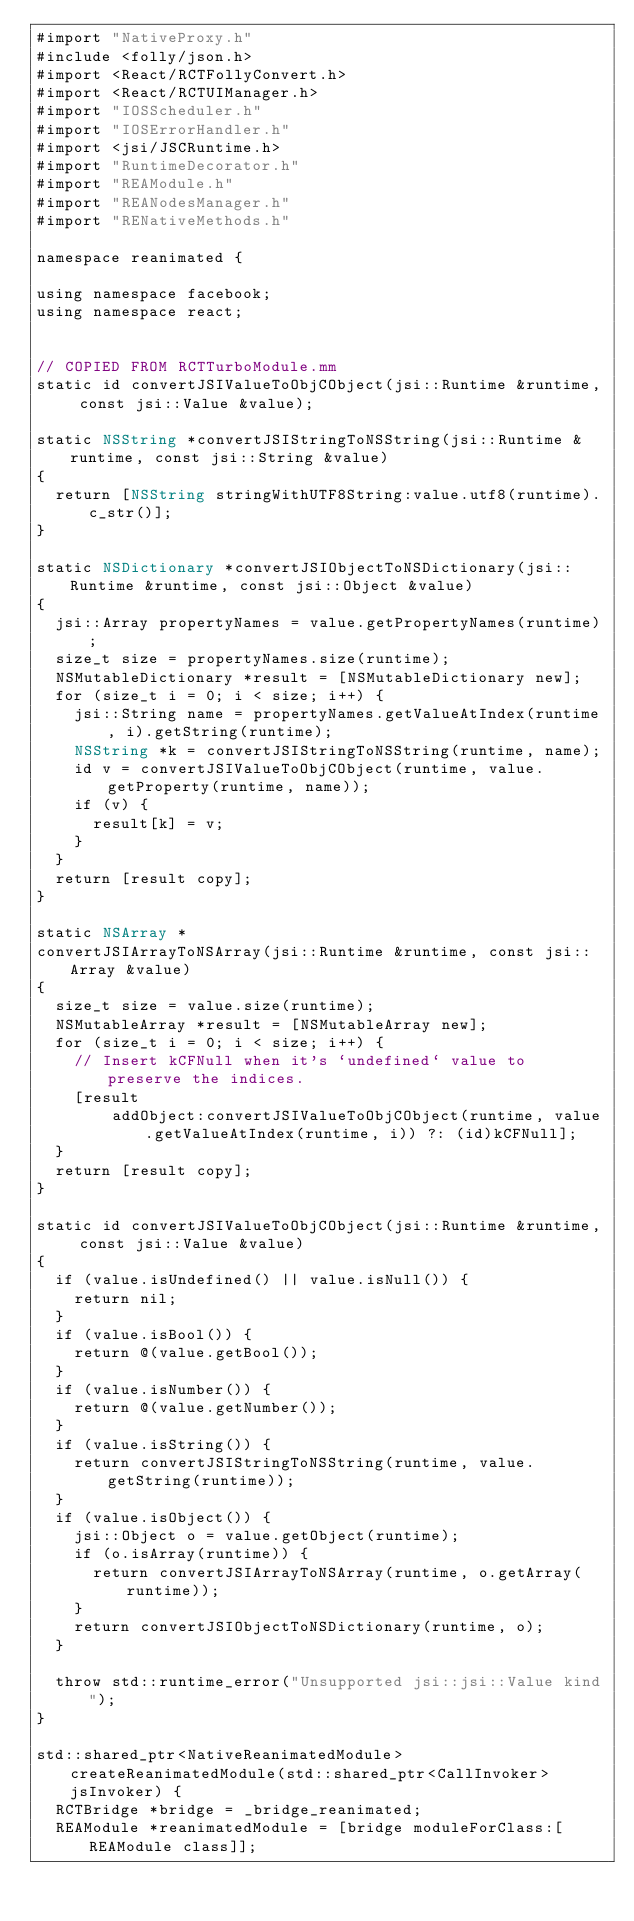<code> <loc_0><loc_0><loc_500><loc_500><_ObjectiveC_>#import "NativeProxy.h"
#include <folly/json.h>
#import <React/RCTFollyConvert.h>
#import <React/RCTUIManager.h>
#import "IOSScheduler.h"
#import "IOSErrorHandler.h"
#import <jsi/JSCRuntime.h>
#import "RuntimeDecorator.h"
#import "REAModule.h"
#import "REANodesManager.h"
#import "RENativeMethods.h"

namespace reanimated {

using namespace facebook;
using namespace react;


// COPIED FROM RCTTurboModule.mm
static id convertJSIValueToObjCObject(jsi::Runtime &runtime, const jsi::Value &value);

static NSString *convertJSIStringToNSString(jsi::Runtime &runtime, const jsi::String &value)
{
  return [NSString stringWithUTF8String:value.utf8(runtime).c_str()];
}

static NSDictionary *convertJSIObjectToNSDictionary(jsi::Runtime &runtime, const jsi::Object &value)
{
  jsi::Array propertyNames = value.getPropertyNames(runtime);
  size_t size = propertyNames.size(runtime);
  NSMutableDictionary *result = [NSMutableDictionary new];
  for (size_t i = 0; i < size; i++) {
    jsi::String name = propertyNames.getValueAtIndex(runtime, i).getString(runtime);
    NSString *k = convertJSIStringToNSString(runtime, name);
    id v = convertJSIValueToObjCObject(runtime, value.getProperty(runtime, name));
    if (v) {
      result[k] = v;
    }
  }
  return [result copy];
}

static NSArray *
convertJSIArrayToNSArray(jsi::Runtime &runtime, const jsi::Array &value)
{
  size_t size = value.size(runtime);
  NSMutableArray *result = [NSMutableArray new];
  for (size_t i = 0; i < size; i++) {
    // Insert kCFNull when it's `undefined` value to preserve the indices.
    [result
        addObject:convertJSIValueToObjCObject(runtime, value.getValueAtIndex(runtime, i)) ?: (id)kCFNull];
  }
  return [result copy];
}

static id convertJSIValueToObjCObject(jsi::Runtime &runtime, const jsi::Value &value)
{
  if (value.isUndefined() || value.isNull()) {
    return nil;
  }
  if (value.isBool()) {
    return @(value.getBool());
  }
  if (value.isNumber()) {
    return @(value.getNumber());
  }
  if (value.isString()) {
    return convertJSIStringToNSString(runtime, value.getString(runtime));
  }
  if (value.isObject()) {
    jsi::Object o = value.getObject(runtime);
    if (o.isArray(runtime)) {
      return convertJSIArrayToNSArray(runtime, o.getArray(runtime));
    }
    return convertJSIObjectToNSDictionary(runtime, o);
  }

  throw std::runtime_error("Unsupported jsi::jsi::Value kind");
}

std::shared_ptr<NativeReanimatedModule> createReanimatedModule(std::shared_ptr<CallInvoker> jsInvoker) {
  RCTBridge *bridge = _bridge_reanimated;
  REAModule *reanimatedModule = [bridge moduleForClass:[REAModule class]];
</code> 